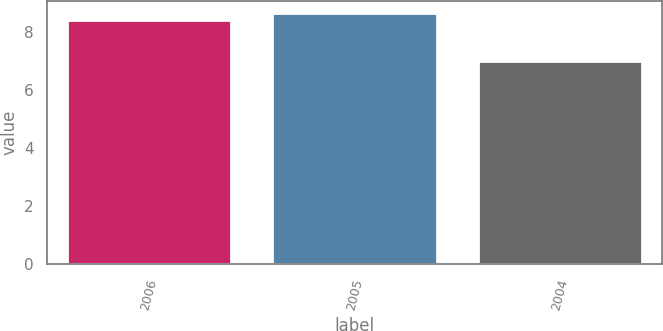<chart> <loc_0><loc_0><loc_500><loc_500><bar_chart><fcel>2006<fcel>2005<fcel>2004<nl><fcel>8.42<fcel>8.64<fcel>7<nl></chart> 